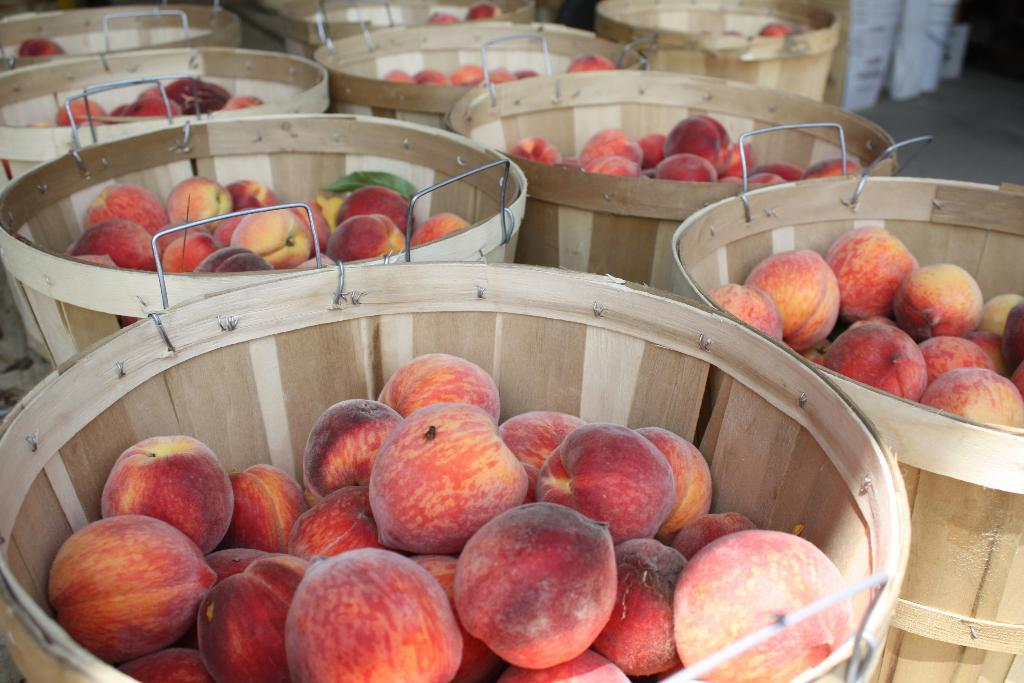What type of containers are present in the image? There are wooden baskets in the image. What items are contained within the wooden baskets? The wooden baskets contain apples. What role does the manager play in the process of digesting the apples in the image? There is no manager present in the image, and the process of digestion is not depicted. 